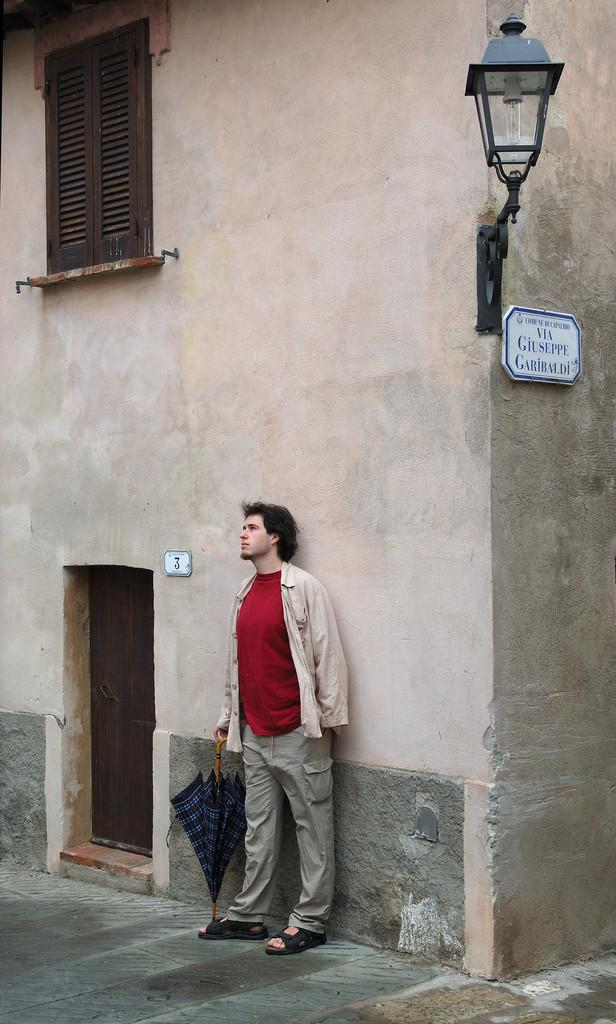Who is in the image? There is a person in the image. What is the person wearing? The person is wearing a dress. What object is the person holding? The person is holding an umbrella. What can be seen in the background of the image? There is a building with windows, light visible, and boards present in the background. What type of beam is being tested in the image? There is no beam present in the image; it features a person holding an umbrella and a background with a building, windows, light, and boards. 